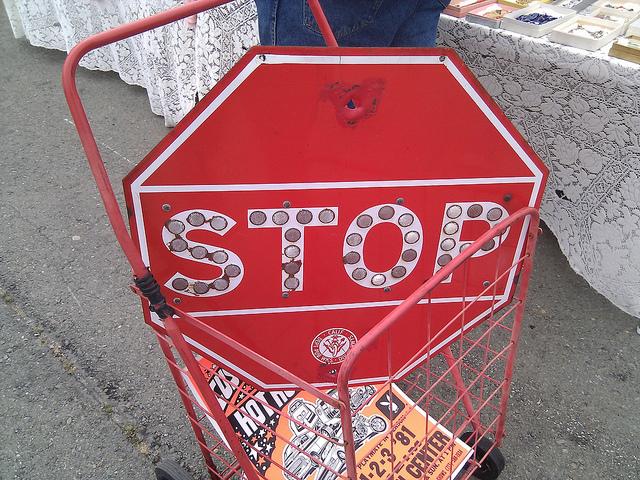Have you ever seen such a stop sign?
Be succinct. No. Is this a rare stop sign?
Be succinct. Yes. How many dots are on the stop sign?
Quick response, please. 38. 